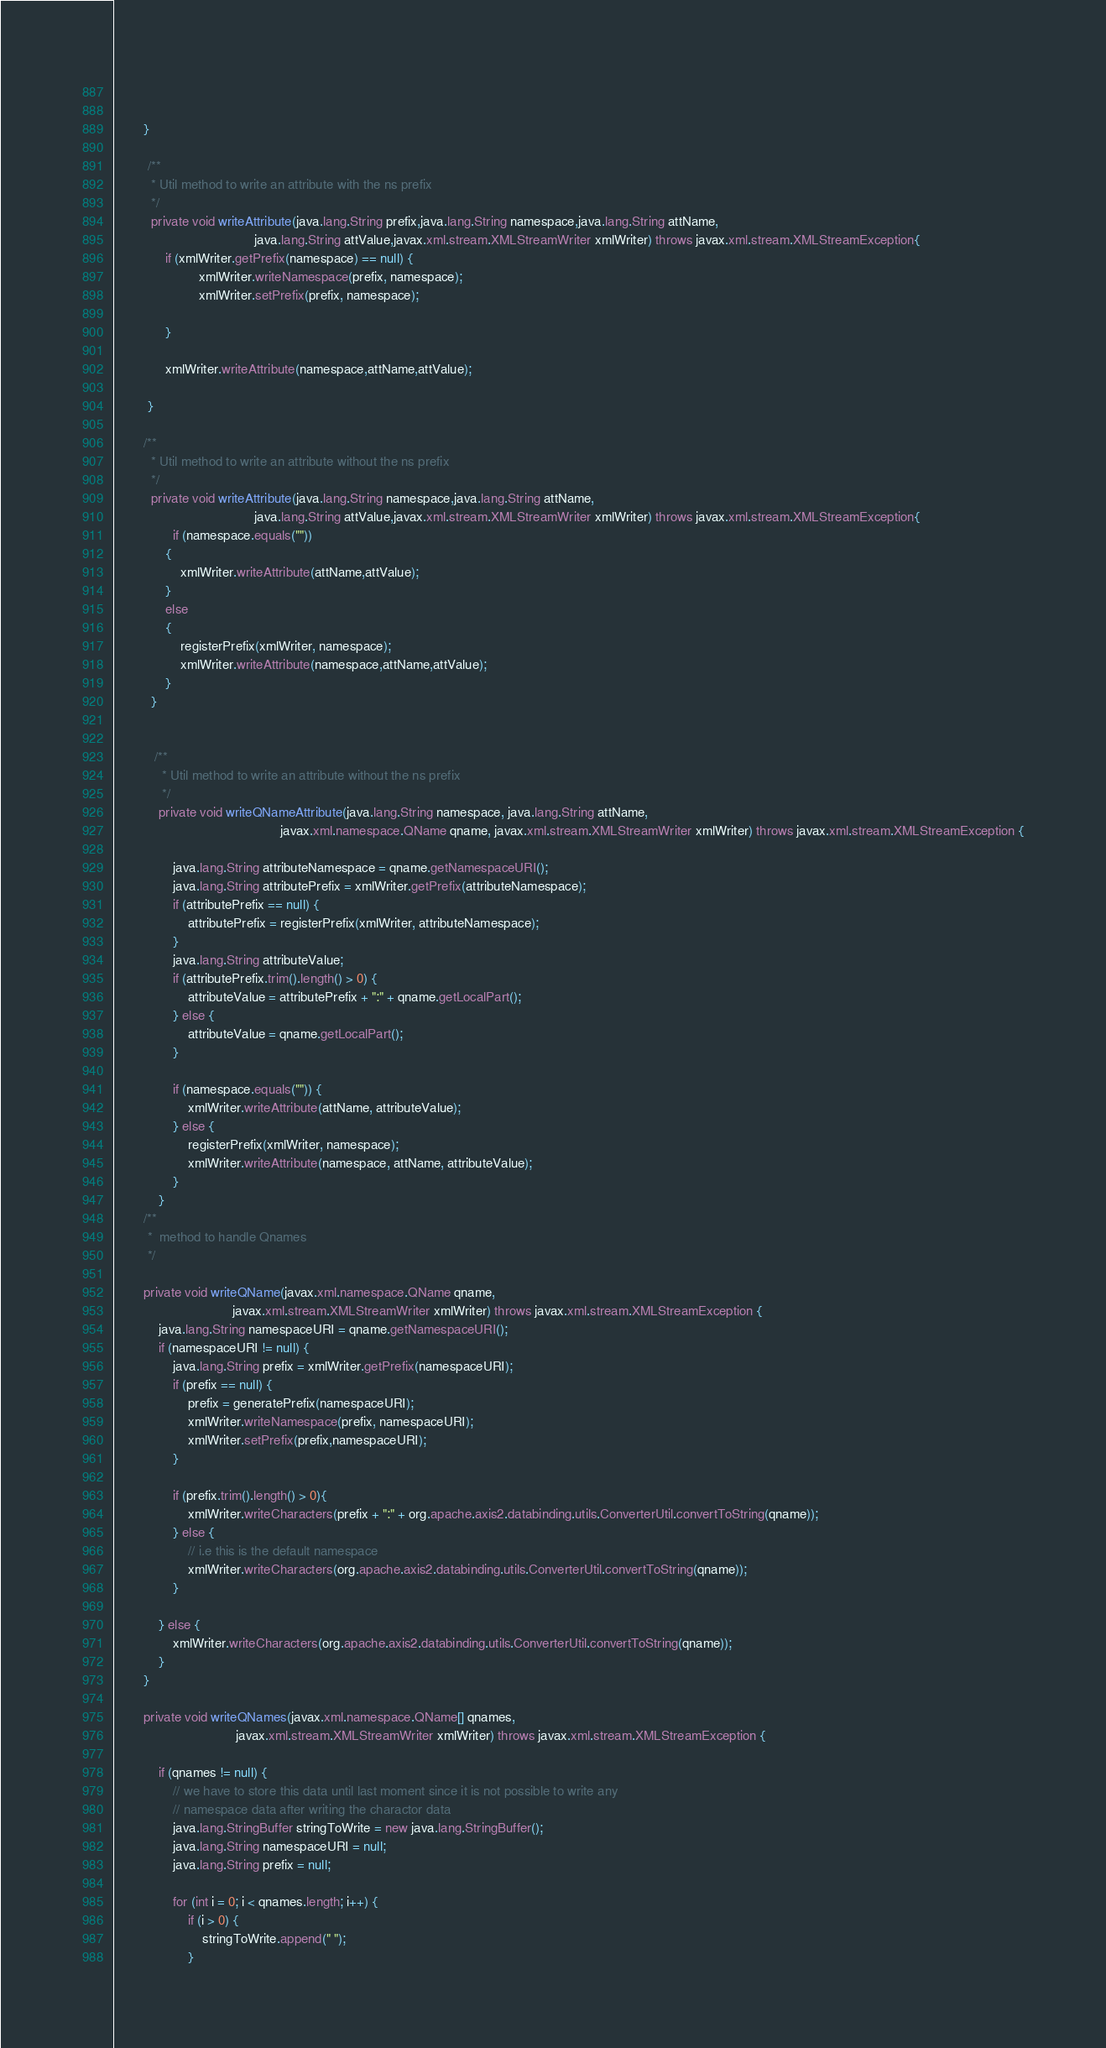Convert code to text. <code><loc_0><loc_0><loc_500><loc_500><_Java_>               

        }

         /**
          * Util method to write an attribute with the ns prefix
          */
          private void writeAttribute(java.lang.String prefix,java.lang.String namespace,java.lang.String attName,
                                      java.lang.String attValue,javax.xml.stream.XMLStreamWriter xmlWriter) throws javax.xml.stream.XMLStreamException{
              if (xmlWriter.getPrefix(namespace) == null) {
                       xmlWriter.writeNamespace(prefix, namespace);
                       xmlWriter.setPrefix(prefix, namespace);

              }

              xmlWriter.writeAttribute(namespace,attName,attValue);

         }

        /**
          * Util method to write an attribute without the ns prefix
          */
          private void writeAttribute(java.lang.String namespace,java.lang.String attName,
                                      java.lang.String attValue,javax.xml.stream.XMLStreamWriter xmlWriter) throws javax.xml.stream.XMLStreamException{
                if (namespace.equals(""))
              {
                  xmlWriter.writeAttribute(attName,attValue);
              }
              else
              {
                  registerPrefix(xmlWriter, namespace);
                  xmlWriter.writeAttribute(namespace,attName,attValue);
              }
          }


           /**
             * Util method to write an attribute without the ns prefix
             */
            private void writeQNameAttribute(java.lang.String namespace, java.lang.String attName,
                                             javax.xml.namespace.QName qname, javax.xml.stream.XMLStreamWriter xmlWriter) throws javax.xml.stream.XMLStreamException {

                java.lang.String attributeNamespace = qname.getNamespaceURI();
                java.lang.String attributePrefix = xmlWriter.getPrefix(attributeNamespace);
                if (attributePrefix == null) {
                    attributePrefix = registerPrefix(xmlWriter, attributeNamespace);
                }
                java.lang.String attributeValue;
                if (attributePrefix.trim().length() > 0) {
                    attributeValue = attributePrefix + ":" + qname.getLocalPart();
                } else {
                    attributeValue = qname.getLocalPart();
                }

                if (namespace.equals("")) {
                    xmlWriter.writeAttribute(attName, attributeValue);
                } else {
                    registerPrefix(xmlWriter, namespace);
                    xmlWriter.writeAttribute(namespace, attName, attributeValue);
                }
            }
        /**
         *  method to handle Qnames
         */

        private void writeQName(javax.xml.namespace.QName qname,
                                javax.xml.stream.XMLStreamWriter xmlWriter) throws javax.xml.stream.XMLStreamException {
            java.lang.String namespaceURI = qname.getNamespaceURI();
            if (namespaceURI != null) {
                java.lang.String prefix = xmlWriter.getPrefix(namespaceURI);
                if (prefix == null) {
                    prefix = generatePrefix(namespaceURI);
                    xmlWriter.writeNamespace(prefix, namespaceURI);
                    xmlWriter.setPrefix(prefix,namespaceURI);
                }

                if (prefix.trim().length() > 0){
                    xmlWriter.writeCharacters(prefix + ":" + org.apache.axis2.databinding.utils.ConverterUtil.convertToString(qname));
                } else {
                    // i.e this is the default namespace
                    xmlWriter.writeCharacters(org.apache.axis2.databinding.utils.ConverterUtil.convertToString(qname));
                }

            } else {
                xmlWriter.writeCharacters(org.apache.axis2.databinding.utils.ConverterUtil.convertToString(qname));
            }
        }

        private void writeQNames(javax.xml.namespace.QName[] qnames,
                                 javax.xml.stream.XMLStreamWriter xmlWriter) throws javax.xml.stream.XMLStreamException {

            if (qnames != null) {
                // we have to store this data until last moment since it is not possible to write any
                // namespace data after writing the charactor data
                java.lang.StringBuffer stringToWrite = new java.lang.StringBuffer();
                java.lang.String namespaceURI = null;
                java.lang.String prefix = null;

                for (int i = 0; i < qnames.length; i++) {
                    if (i > 0) {
                        stringToWrite.append(" ");
                    }</code> 